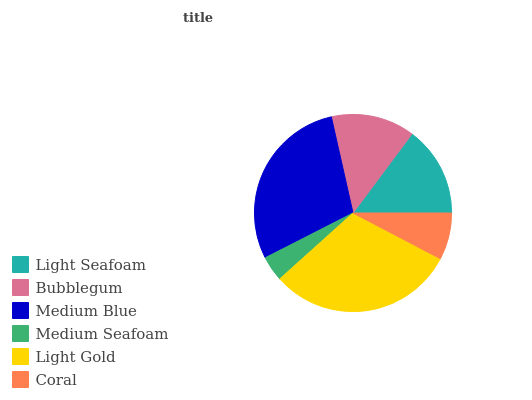Is Medium Seafoam the minimum?
Answer yes or no. Yes. Is Light Gold the maximum?
Answer yes or no. Yes. Is Bubblegum the minimum?
Answer yes or no. No. Is Bubblegum the maximum?
Answer yes or no. No. Is Light Seafoam greater than Bubblegum?
Answer yes or no. Yes. Is Bubblegum less than Light Seafoam?
Answer yes or no. Yes. Is Bubblegum greater than Light Seafoam?
Answer yes or no. No. Is Light Seafoam less than Bubblegum?
Answer yes or no. No. Is Light Seafoam the high median?
Answer yes or no. Yes. Is Bubblegum the low median?
Answer yes or no. Yes. Is Bubblegum the high median?
Answer yes or no. No. Is Medium Seafoam the low median?
Answer yes or no. No. 